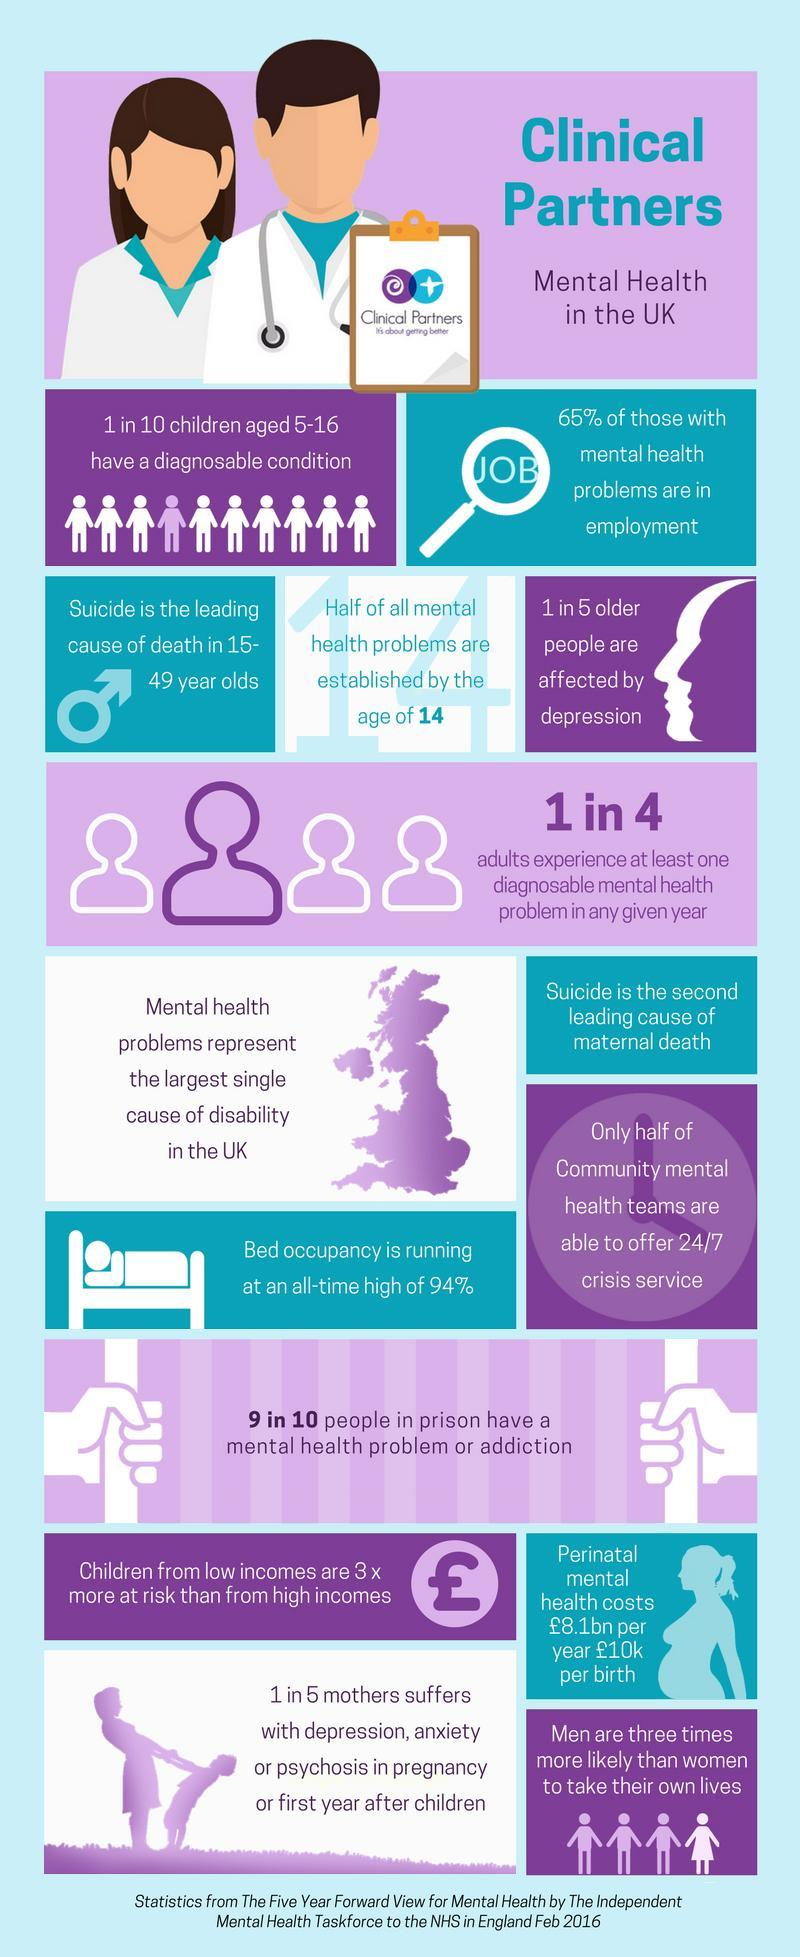List a handful of essential elements in this visual. Most mental health problems typically begin during childhood and adolescence, with the age of 14 being a significant age for the onset of such issues. The major cause of death among people in the age range 15 to 49 is suicide. Out of the sample of 5 individuals, 4 individuals are not experiencing depression. According to data from the UK, approximately 35% of people in the employment sector do not have any mental health problems. 